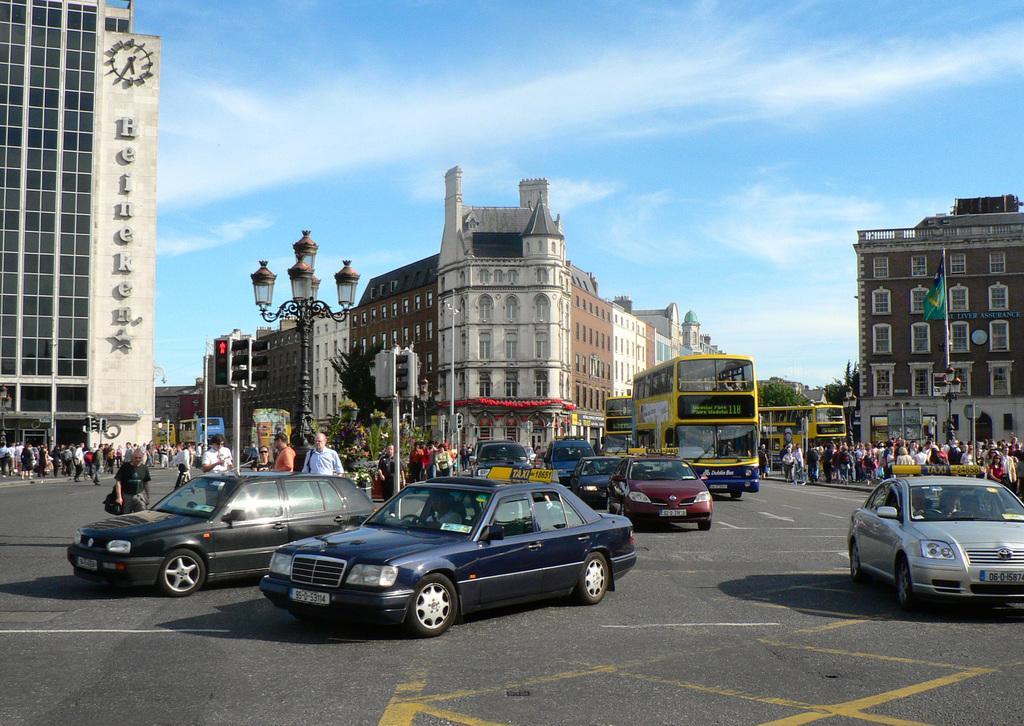Please provide a concise description of this image. In the foreground of the image we can see cars and some people are walking on the road. In the middle of the image we can see the buildings. On the top of the image we can see the sky. 